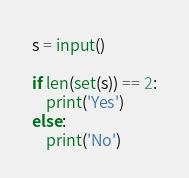<code> <loc_0><loc_0><loc_500><loc_500><_Python_>s = input()

if len(set(s)) == 2:
    print('Yes')
else:
    print('No')</code> 